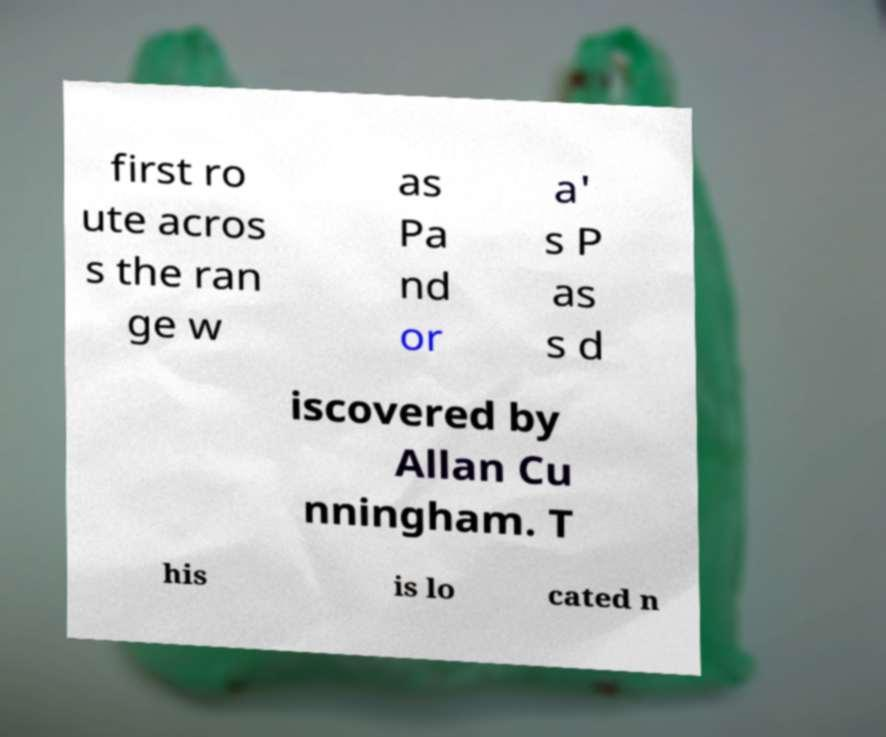There's text embedded in this image that I need extracted. Can you transcribe it verbatim? first ro ute acros s the ran ge w as Pa nd or a' s P as s d iscovered by Allan Cu nningham. T his is lo cated n 